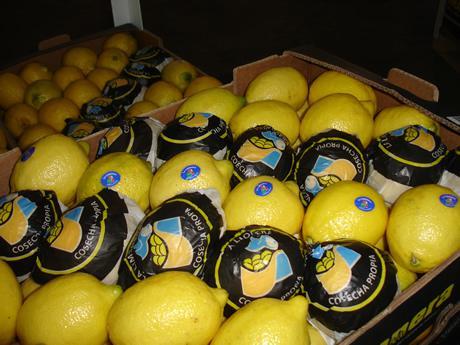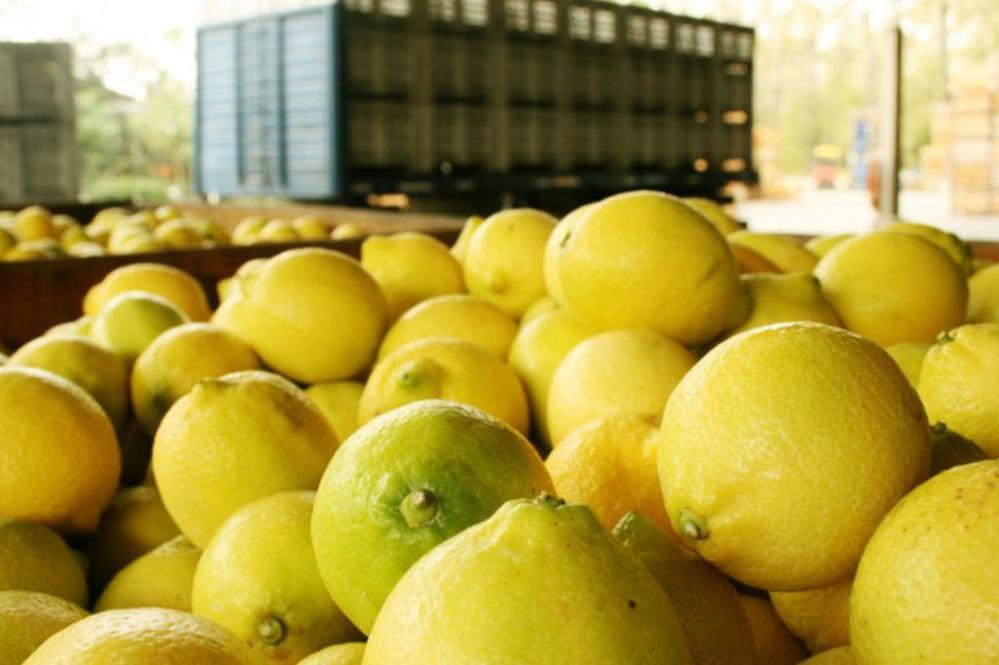The first image is the image on the left, the second image is the image on the right. Considering the images on both sides, is "Some of the lemons are packaged." valid? Answer yes or no. Yes. The first image is the image on the left, the second image is the image on the right. Evaluate the accuracy of this statement regarding the images: "In at least one image there is a box of lemons with at least six that have blue stickers.". Is it true? Answer yes or no. Yes. 